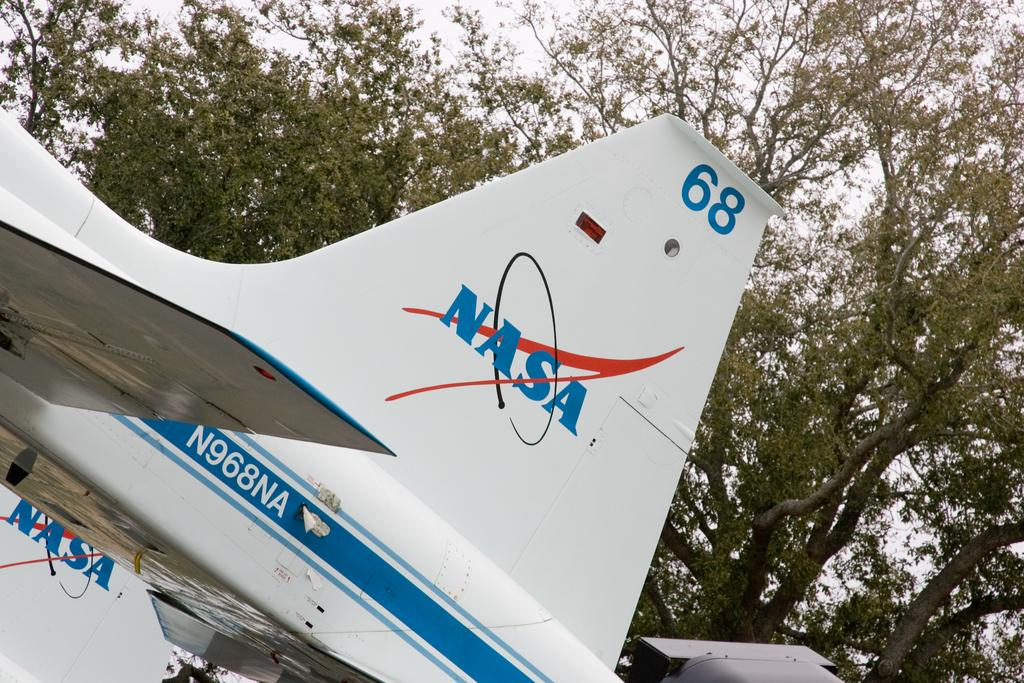Provide a one-sentence caption for the provided image. The tail fin of a NASA space shuttle. 